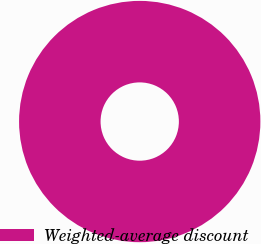<chart> <loc_0><loc_0><loc_500><loc_500><pie_chart><fcel>Weighted-average discount<nl><fcel>100.0%<nl></chart> 